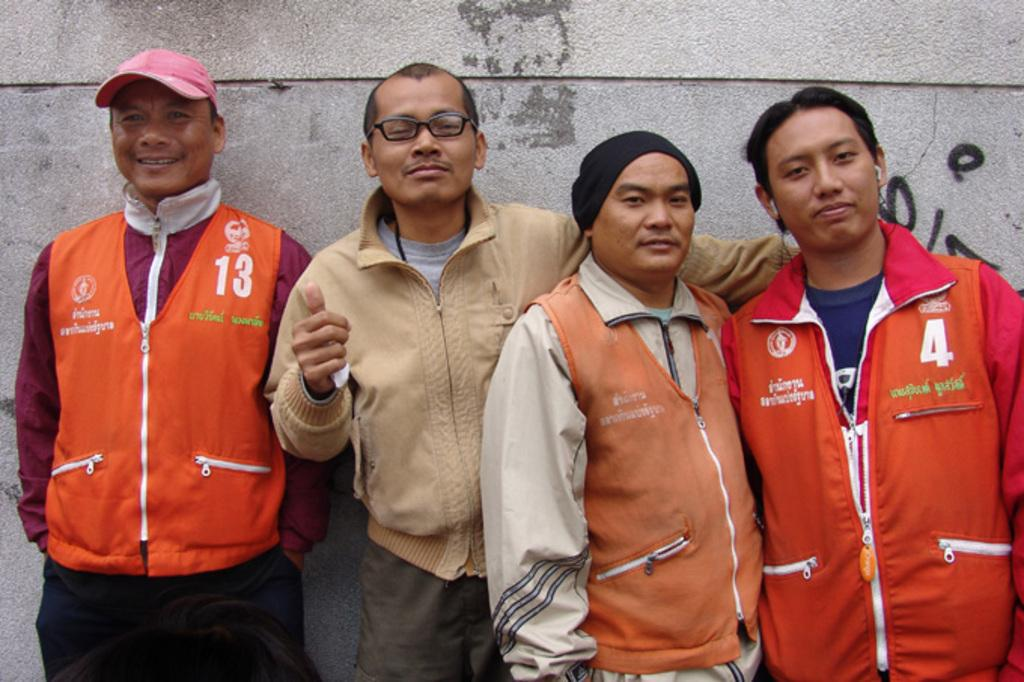<image>
Present a compact description of the photo's key features. a man wearing number 13 vest is on the left 